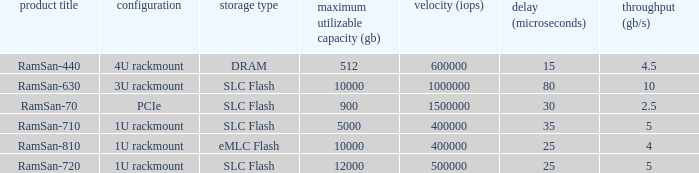List the range distroration for the ramsan-630 3U rackmount. 